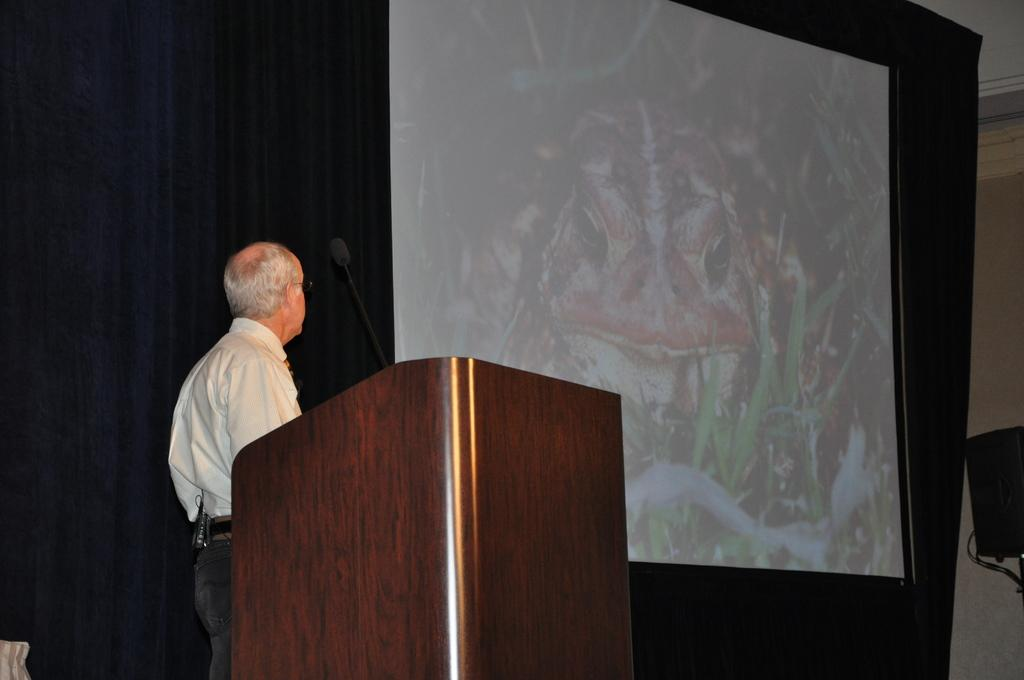Who is the main subject in the foreground of the image? There is a man in the foreground of the image. What is the man standing in front of? The man is standing in front of a podium. What is on the podium? There is a mic on the podium. What is visible behind the man? There is a curtain and a screen behind the man. What is on the right side of the image? There is a wall on the right side of the image. What type of doll is sitting on the wall in the image? There is no doll present in the image; the wall on the right side of the image is empty. 